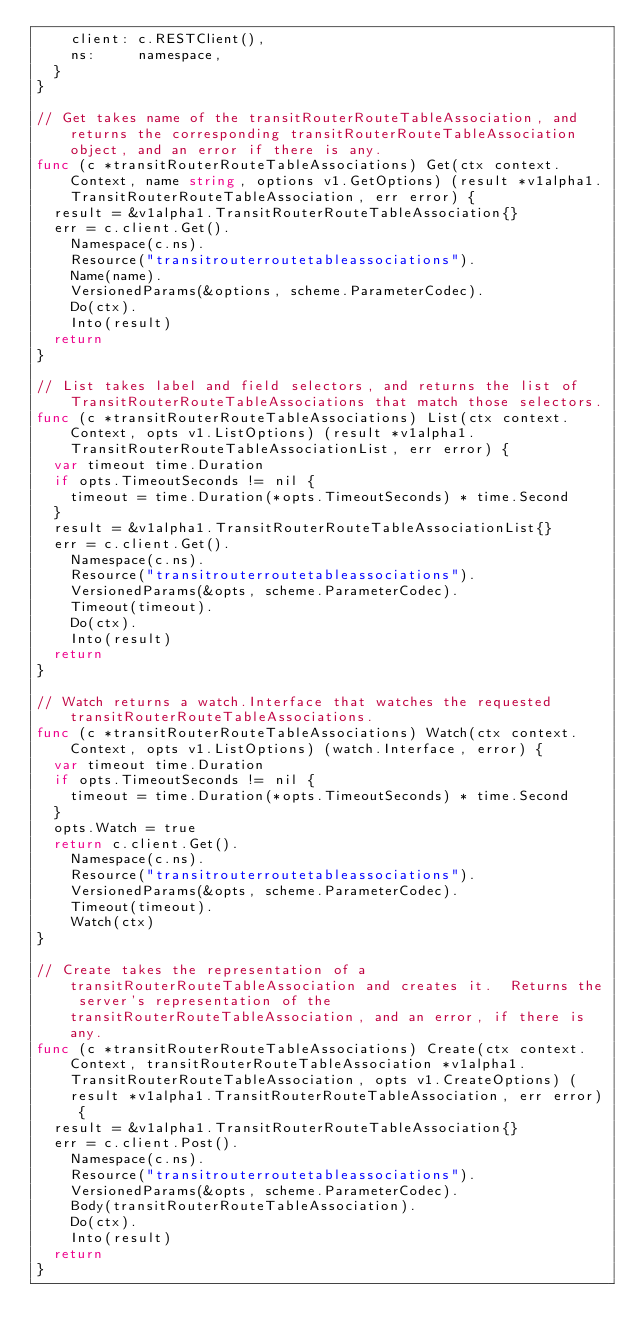Convert code to text. <code><loc_0><loc_0><loc_500><loc_500><_Go_>		client: c.RESTClient(),
		ns:     namespace,
	}
}

// Get takes name of the transitRouterRouteTableAssociation, and returns the corresponding transitRouterRouteTableAssociation object, and an error if there is any.
func (c *transitRouterRouteTableAssociations) Get(ctx context.Context, name string, options v1.GetOptions) (result *v1alpha1.TransitRouterRouteTableAssociation, err error) {
	result = &v1alpha1.TransitRouterRouteTableAssociation{}
	err = c.client.Get().
		Namespace(c.ns).
		Resource("transitrouterroutetableassociations").
		Name(name).
		VersionedParams(&options, scheme.ParameterCodec).
		Do(ctx).
		Into(result)
	return
}

// List takes label and field selectors, and returns the list of TransitRouterRouteTableAssociations that match those selectors.
func (c *transitRouterRouteTableAssociations) List(ctx context.Context, opts v1.ListOptions) (result *v1alpha1.TransitRouterRouteTableAssociationList, err error) {
	var timeout time.Duration
	if opts.TimeoutSeconds != nil {
		timeout = time.Duration(*opts.TimeoutSeconds) * time.Second
	}
	result = &v1alpha1.TransitRouterRouteTableAssociationList{}
	err = c.client.Get().
		Namespace(c.ns).
		Resource("transitrouterroutetableassociations").
		VersionedParams(&opts, scheme.ParameterCodec).
		Timeout(timeout).
		Do(ctx).
		Into(result)
	return
}

// Watch returns a watch.Interface that watches the requested transitRouterRouteTableAssociations.
func (c *transitRouterRouteTableAssociations) Watch(ctx context.Context, opts v1.ListOptions) (watch.Interface, error) {
	var timeout time.Duration
	if opts.TimeoutSeconds != nil {
		timeout = time.Duration(*opts.TimeoutSeconds) * time.Second
	}
	opts.Watch = true
	return c.client.Get().
		Namespace(c.ns).
		Resource("transitrouterroutetableassociations").
		VersionedParams(&opts, scheme.ParameterCodec).
		Timeout(timeout).
		Watch(ctx)
}

// Create takes the representation of a transitRouterRouteTableAssociation and creates it.  Returns the server's representation of the transitRouterRouteTableAssociation, and an error, if there is any.
func (c *transitRouterRouteTableAssociations) Create(ctx context.Context, transitRouterRouteTableAssociation *v1alpha1.TransitRouterRouteTableAssociation, opts v1.CreateOptions) (result *v1alpha1.TransitRouterRouteTableAssociation, err error) {
	result = &v1alpha1.TransitRouterRouteTableAssociation{}
	err = c.client.Post().
		Namespace(c.ns).
		Resource("transitrouterroutetableassociations").
		VersionedParams(&opts, scheme.ParameterCodec).
		Body(transitRouterRouteTableAssociation).
		Do(ctx).
		Into(result)
	return
}
</code> 